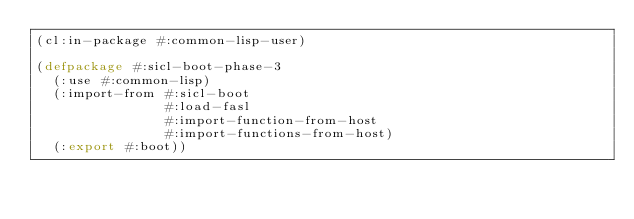<code> <loc_0><loc_0><loc_500><loc_500><_Lisp_>(cl:in-package #:common-lisp-user)

(defpackage #:sicl-boot-phase-3
  (:use #:common-lisp)
  (:import-from #:sicl-boot
                #:load-fasl
                #:import-function-from-host
                #:import-functions-from-host)
  (:export #:boot))
</code> 